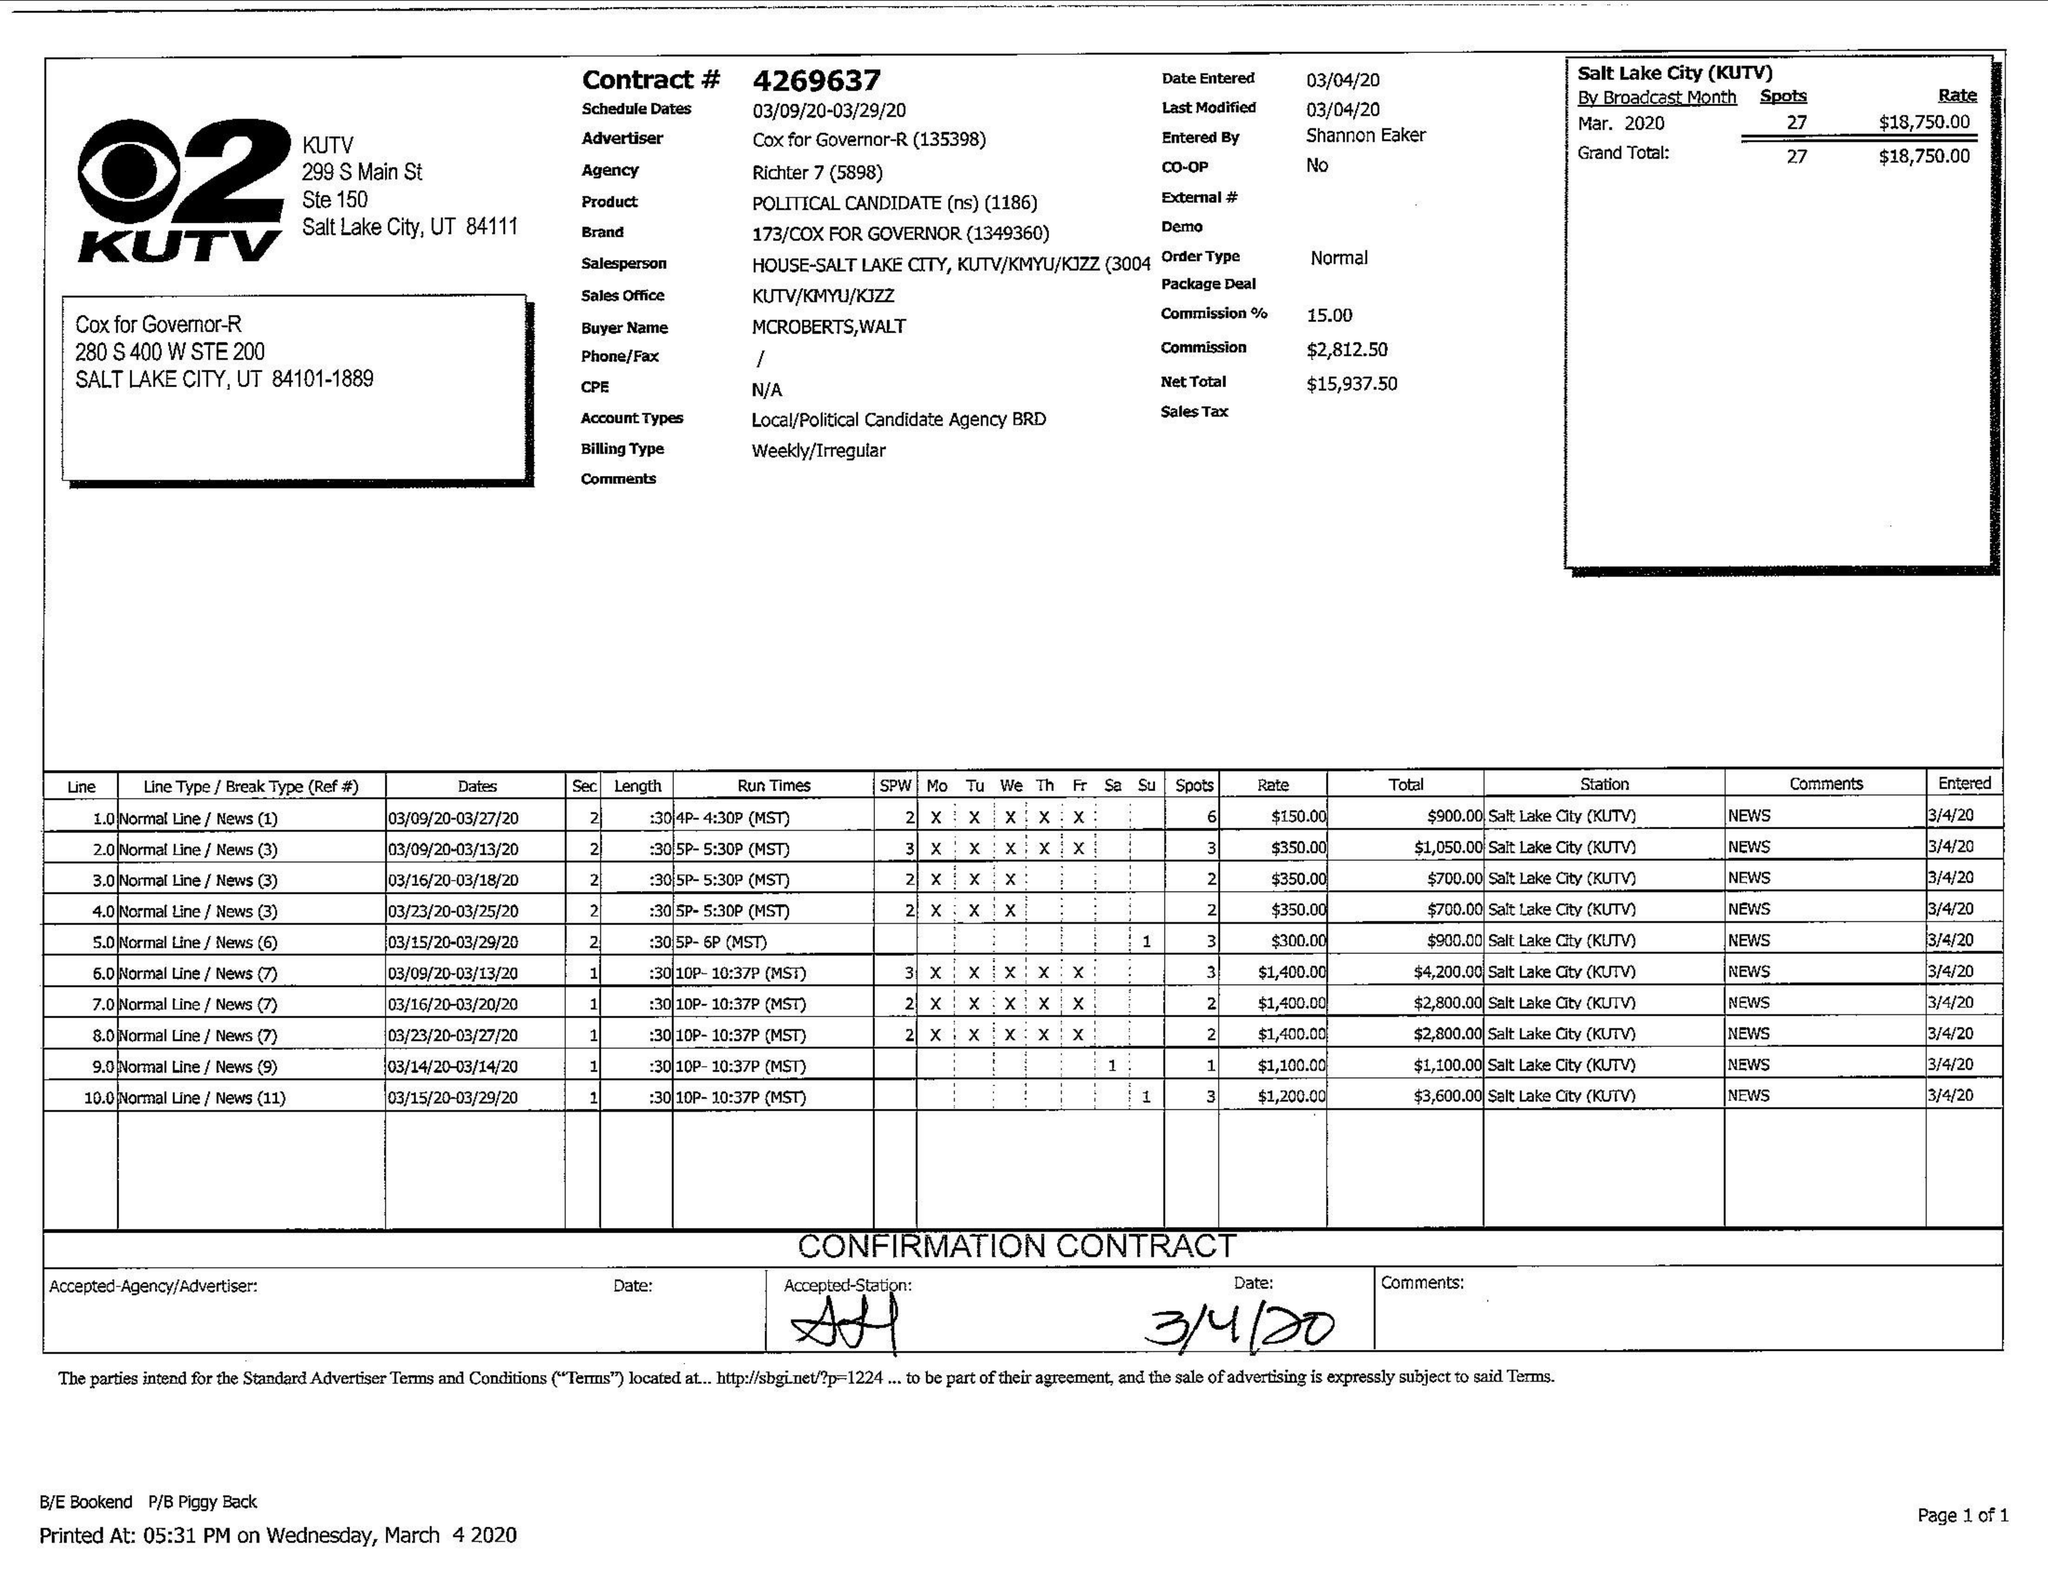What is the value for the flight_to?
Answer the question using a single word or phrase. 03/29/20 